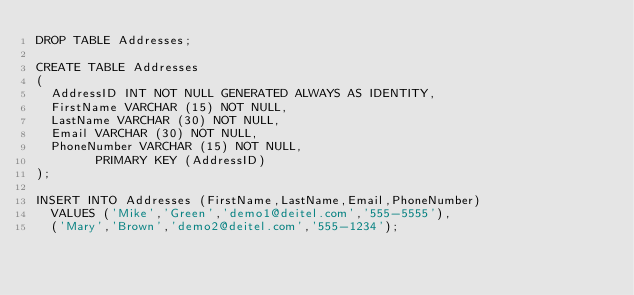<code> <loc_0><loc_0><loc_500><loc_500><_SQL_>DROP TABLE Addresses;

CREATE TABLE Addresses
(
	AddressID INT NOT NULL GENERATED ALWAYS AS IDENTITY,
	FirstName VARCHAR (15) NOT NULL,
	LastName VARCHAR (30) NOT NULL,
	Email VARCHAR (30) NOT NULL,
	PhoneNumber VARCHAR (15) NOT NULL,
        PRIMARY KEY (AddressID)
);

INSERT INTO Addresses (FirstName,LastName,Email,PhoneNumber)
	VALUES ('Mike','Green','demo1@deitel.com','555-5555'),
	('Mary','Brown','demo2@deitel.com','555-1234');</code> 